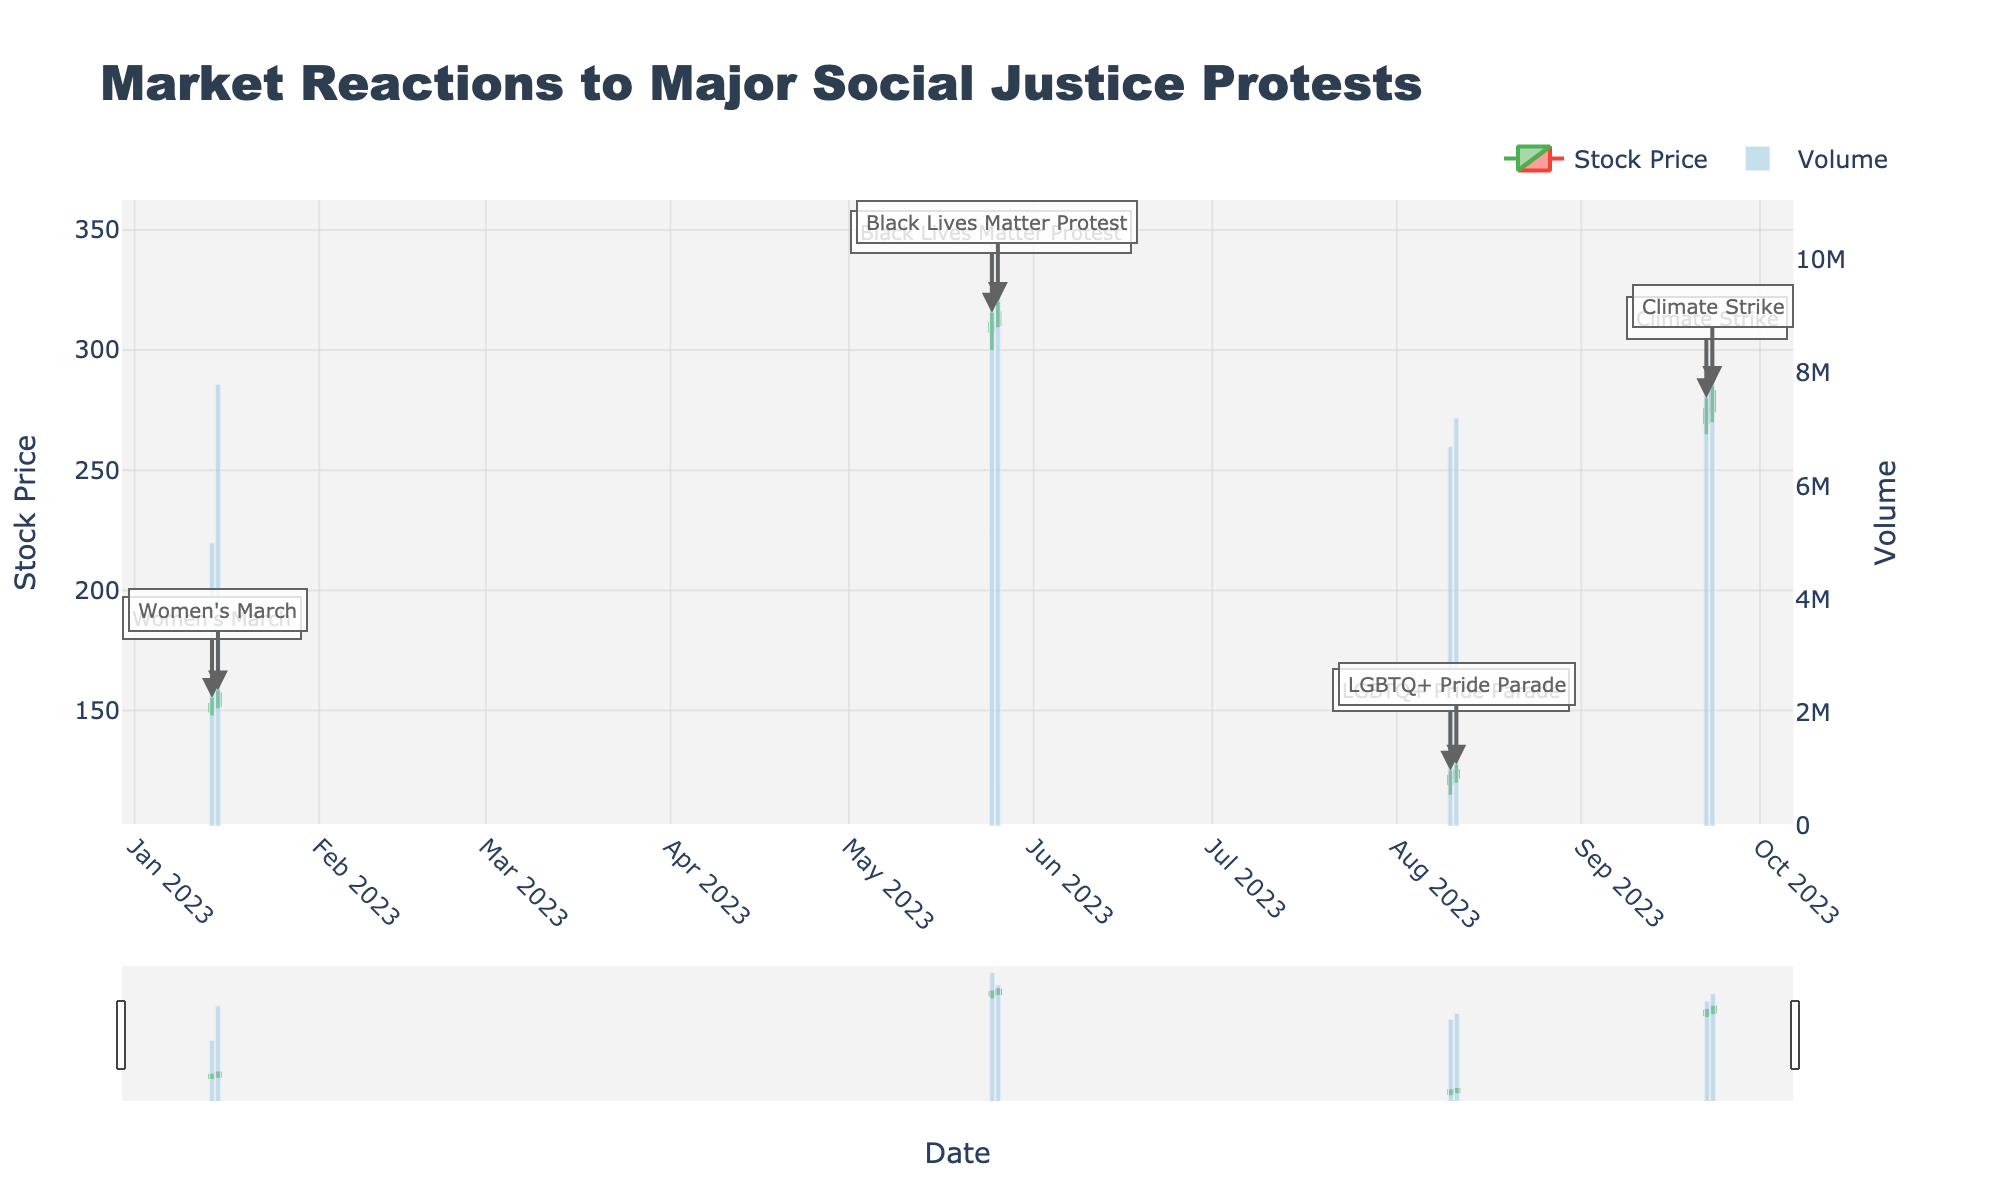When did the highest Volume occur, and what was the corresponding event? The highest volume can be identified by looking for the tallest bar in the volume chart. The tallest bar represents a volume of 10,500,000 on 2023-05-25 during the Black Lives Matter Protest.
Answer: 2023-05-25, Black Lives Matter Protest What is the range of stock prices during Women's March? The range of stock prices can be calculated by identifying the lowest low and highest high during the event dates. On 2023-01-14, the lowest low was 148.00, and the highest high was 155.20. On 2023-01-15, the lowest low was 151.00, and the highest high was 158.40. Therefore, the lowest low is 148.00 and the highest high is 158.40, making the range 158.40 - 148.00 = 10.40.
Answer: 10.40 Compare the closing price trends between the two days of the Black Lives Matter Protest. For the Black Lives Matter Protest, the closing prices were 310.80 on the first day and 315.20 on the second day. The closing price increased from 310.80 to 315.20.
Answer: Increased What was the stock price on 2023-08-10's open and close? Referring to the candlestick for 2023-08-10, the "open" price is shown at the start of the candlestick body and the "close" price is at the end of the body. On 2023-08-10, the stock opened at 120.00 and closed at 122.50.
Answer: Open: 120.00, Close: 122.50 Which event day had the largest difference between the high and low prices? To find the largest difference, look at the high and low prices for each day and calculate the difference. Women's March Day 2: 158.40 - 151.00 = 7.40, Black Lives Matter Day 1: 315.50 - 300.00 = 15.50, Black Lives Matter Day 2: 320.00 - 309.50 = 10.50, LGBTQ+ Day 1: 125.00 - 115.00 = 10.00, LGBTQ+ Day 2: 127.50 - 120.00 = 7.50, Climate Strike Day 1: 280.00 - 265.00 = 15.00, Climate Strike Day 2: 285.00 - 270.00 = 15.00. Thus, 2023-05-25 had the largest difference of 15.50 during Black Lives Matter Protest.
Answer: 2023-05-25 What trend in stock prices can be observed during the Climate Strike? By examining the closing prices of the Climate Strike, the stock price closed at 275.00 on 2023-09-22 and increased to 282.50 on 2023-09-23. This indicates an upward trend.
Answer: Upward How did the volume change between the two days of the LGBTQ+ Pride Parade? For the LGBTQ+ Pride Parade, the volume on 2023-08-10 was 6,700,000, and on 2023-08-11, it was 7,200,000. The volume increased by 7,200,000 - 6,700,000 = 500,000.
Answer: Increased by 500,000 What is the average closing price of the stock during all events? Calculate the average by summing all closing prices and dividing by the number of events. The closing prices are: 152.30, 156.70, 310.80, 315.20, 122.50, 124.80, 275.00, 282.50. The sum is 1740.80, and dividing by 8 gives 1740.80 / 8 = 217.60.
Answer: 217.60 